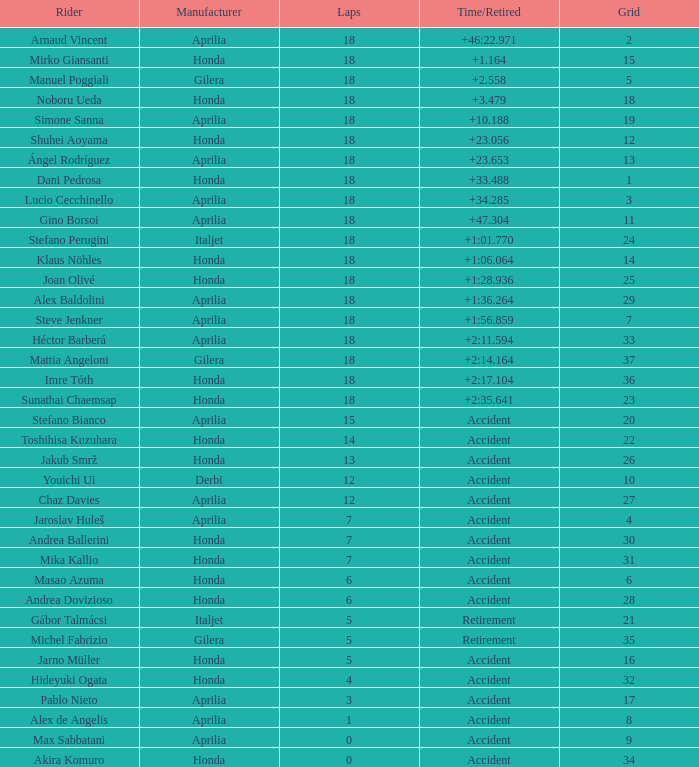What is the period/retirement for the honda maker with a grid smaller than 26, 18 laps, and joan olivé as the rider? +1:28.936. 